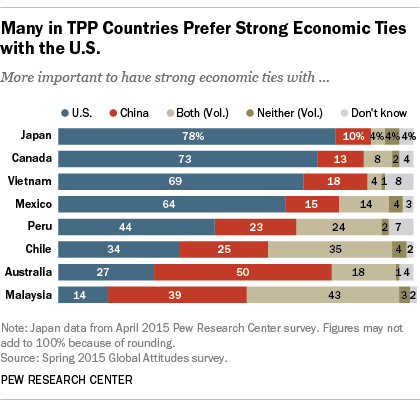List a handful of essential elements in this visual. The largest value corresponds to the United States is 78.. The chart shows a red bar representing data from China, which is the country indicated by the chart. 